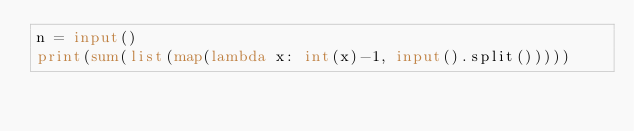Convert code to text. <code><loc_0><loc_0><loc_500><loc_500><_Python_>n = input()
print(sum(list(map(lambda x: int(x)-1, input().split()))))</code> 